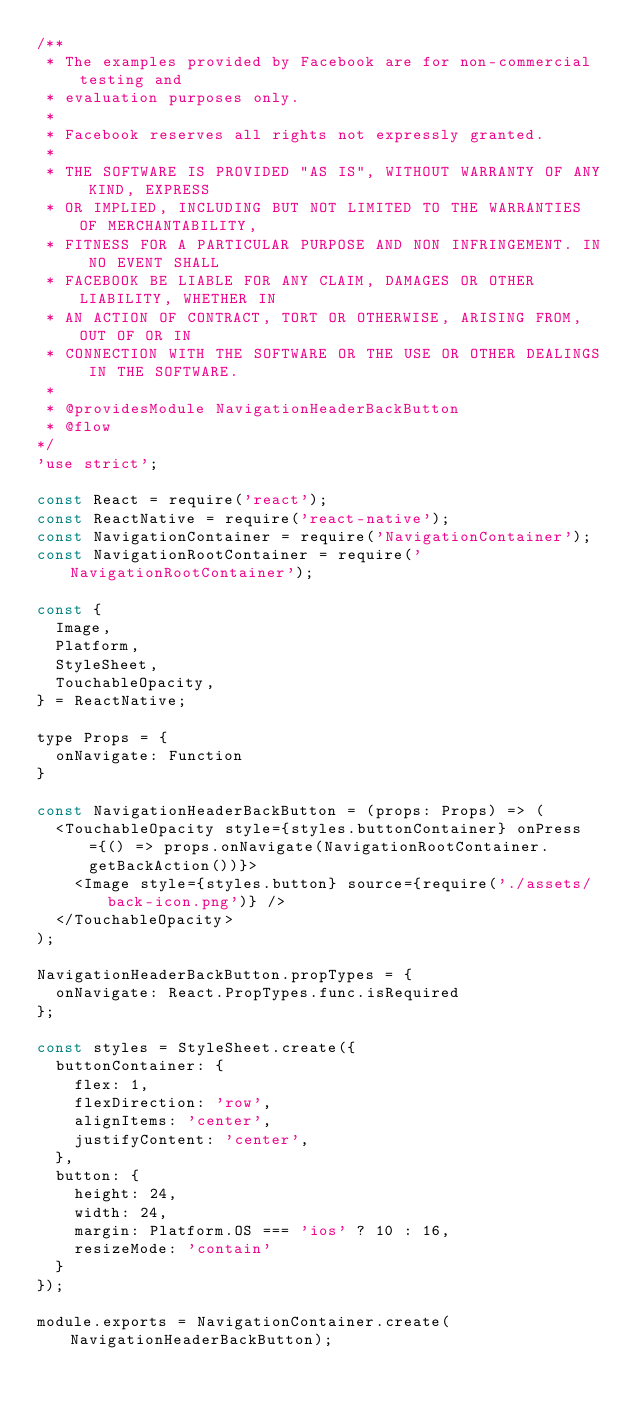<code> <loc_0><loc_0><loc_500><loc_500><_JavaScript_>/**
 * The examples provided by Facebook are for non-commercial testing and
 * evaluation purposes only.
 *
 * Facebook reserves all rights not expressly granted.
 *
 * THE SOFTWARE IS PROVIDED "AS IS", WITHOUT WARRANTY OF ANY KIND, EXPRESS
 * OR IMPLIED, INCLUDING BUT NOT LIMITED TO THE WARRANTIES OF MERCHANTABILITY,
 * FITNESS FOR A PARTICULAR PURPOSE AND NON INFRINGEMENT. IN NO EVENT SHALL
 * FACEBOOK BE LIABLE FOR ANY CLAIM, DAMAGES OR OTHER LIABILITY, WHETHER IN
 * AN ACTION OF CONTRACT, TORT OR OTHERWISE, ARISING FROM, OUT OF OR IN
 * CONNECTION WITH THE SOFTWARE OR THE USE OR OTHER DEALINGS IN THE SOFTWARE.
 *
 * @providesModule NavigationHeaderBackButton
 * @flow
*/
'use strict';

const React = require('react');
const ReactNative = require('react-native');
const NavigationContainer = require('NavigationContainer');
const NavigationRootContainer = require('NavigationRootContainer');

const {
  Image,
  Platform,
  StyleSheet,
  TouchableOpacity,
} = ReactNative;

type Props = {
  onNavigate: Function
}

const NavigationHeaderBackButton = (props: Props) => (
  <TouchableOpacity style={styles.buttonContainer} onPress={() => props.onNavigate(NavigationRootContainer.getBackAction())}>
    <Image style={styles.button} source={require('./assets/back-icon.png')} />
  </TouchableOpacity>
);

NavigationHeaderBackButton.propTypes = {
  onNavigate: React.PropTypes.func.isRequired
};

const styles = StyleSheet.create({
  buttonContainer: {
    flex: 1,
    flexDirection: 'row',
    alignItems: 'center',
    justifyContent: 'center',
  },
  button: {
    height: 24,
    width: 24,
    margin: Platform.OS === 'ios' ? 10 : 16,
    resizeMode: 'contain'
  }
});

module.exports = NavigationContainer.create(NavigationHeaderBackButton);
</code> 